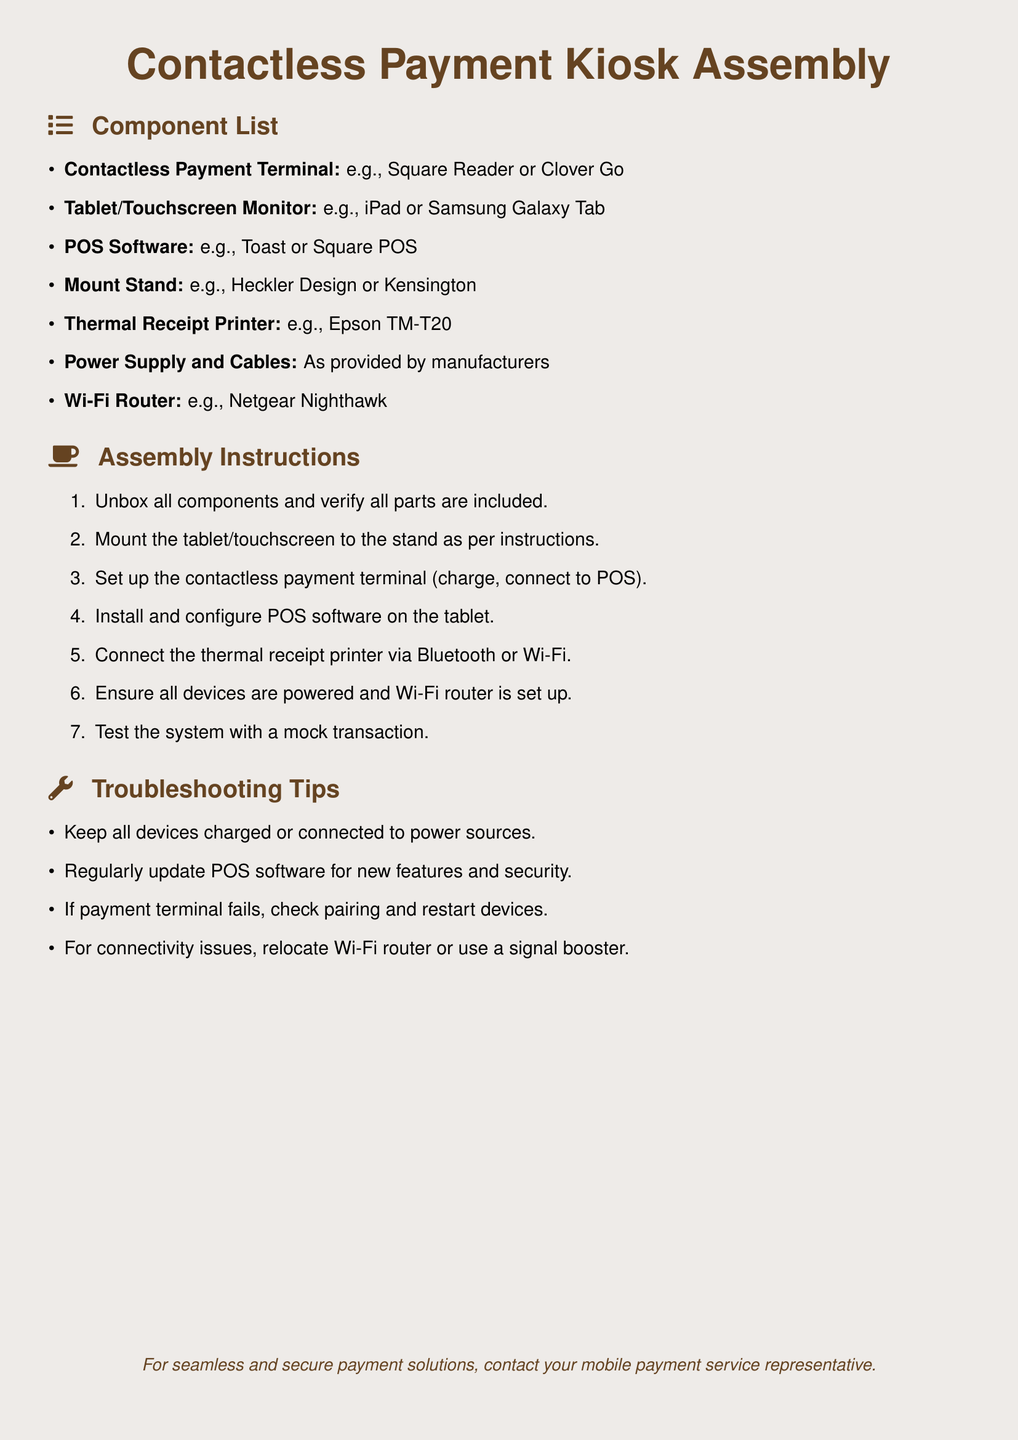What are the components needed for the kiosk? The component list includes items like the contactless payment terminal, tablet, POS software, etc.
Answer: Contactless Payment Terminal, Tablet, POS Software, Mount Stand, Thermal Receipt Printer, Power Supply and Cables, Wi-Fi Router How many steps are in the assembly instructions? The assembly instructions consist of a sequence of steps that total seven.
Answer: 7 What type of printer is recommended? The document specifies a particular model of thermal receipt printer to be used.
Answer: Epson TM-T20 Which operating system is mentioned for the tablet? The document suggests specific tablets compatible with the assembly instructions; one mentioned is an iPad.
Answer: iPad What is the purpose of the Wi-Fi router in this setup? The Wi-Fi router's role is to provide internet connectivity which is essential for the POS system.
Answer: Connectivity What should you do if the payment terminal fails? The troubleshooting tips suggest checking the pairing and restarting devices to resolve issues.
Answer: Check pairing and restart devices How should the devices be powered? The troubleshooting advice indicates that all devices should be charged or connected to power sources.
Answer: Charged or connected to power sources What might you do for connectivity issues? Relocating the Wi-Fi router is one suggested solution for resolving connectivity problems.
Answer: Relocate Wi-Fi router What is the last step in the assembly instructions? The final step in testing ensures that the entire system works correctly with a mock transaction.
Answer: Test the system with a mock transaction 